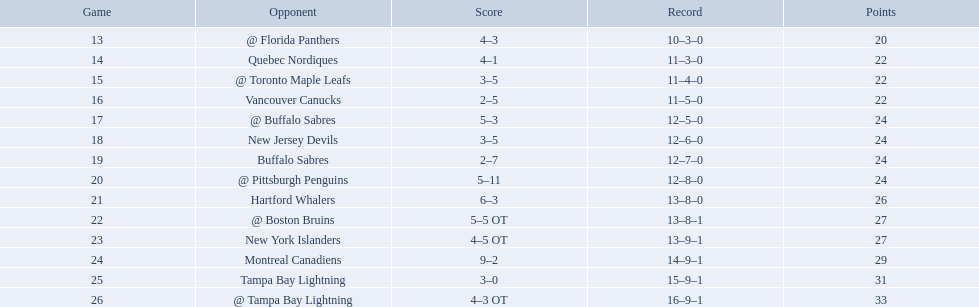Which teams scored 35 points or more in total? Hartford Whalers, @ Boston Bruins, New York Islanders, Montreal Canadiens, Tampa Bay Lightning, @ Tampa Bay Lightning. Of those teams, which team was the only one to score 3-0? Tampa Bay Lightning. What are the teams in the atlantic division? Quebec Nordiques, Vancouver Canucks, New Jersey Devils, Buffalo Sabres, Hartford Whalers, New York Islanders, Montreal Canadiens, Tampa Bay Lightning. Which of those scored fewer points than the philadelphia flyers? Tampa Bay Lightning. What were the scores? @ Florida Panthers, 4–3, Quebec Nordiques, 4–1, @ Toronto Maple Leafs, 3–5, Vancouver Canucks, 2–5, @ Buffalo Sabres, 5–3, New Jersey Devils, 3–5, Buffalo Sabres, 2–7, @ Pittsburgh Penguins, 5–11, Hartford Whalers, 6–3, @ Boston Bruins, 5–5 OT, New York Islanders, 4–5 OT, Montreal Canadiens, 9–2, Tampa Bay Lightning, 3–0, @ Tampa Bay Lightning, 4–3 OT. What score was the closest? New York Islanders, 4–5 OT. What team had that score? New York Islanders. 